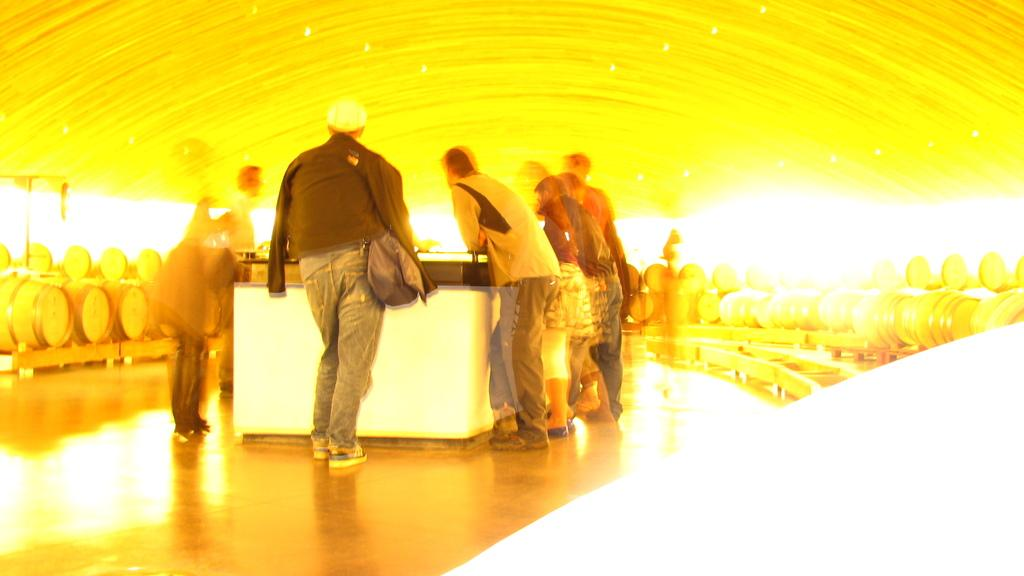What are the people in the image doing? The people in the image are standing in front of a table. Can you describe the clothing of one of the people? One person is wearing a bag. What else can be seen around the people? There are objects around the people. What colors are visible in the shade in the image? There is a yellow and white shade visible in the image. What type of club is being used by the people in the image? There is no club present in the image; the people are simply standing in front of a table. 